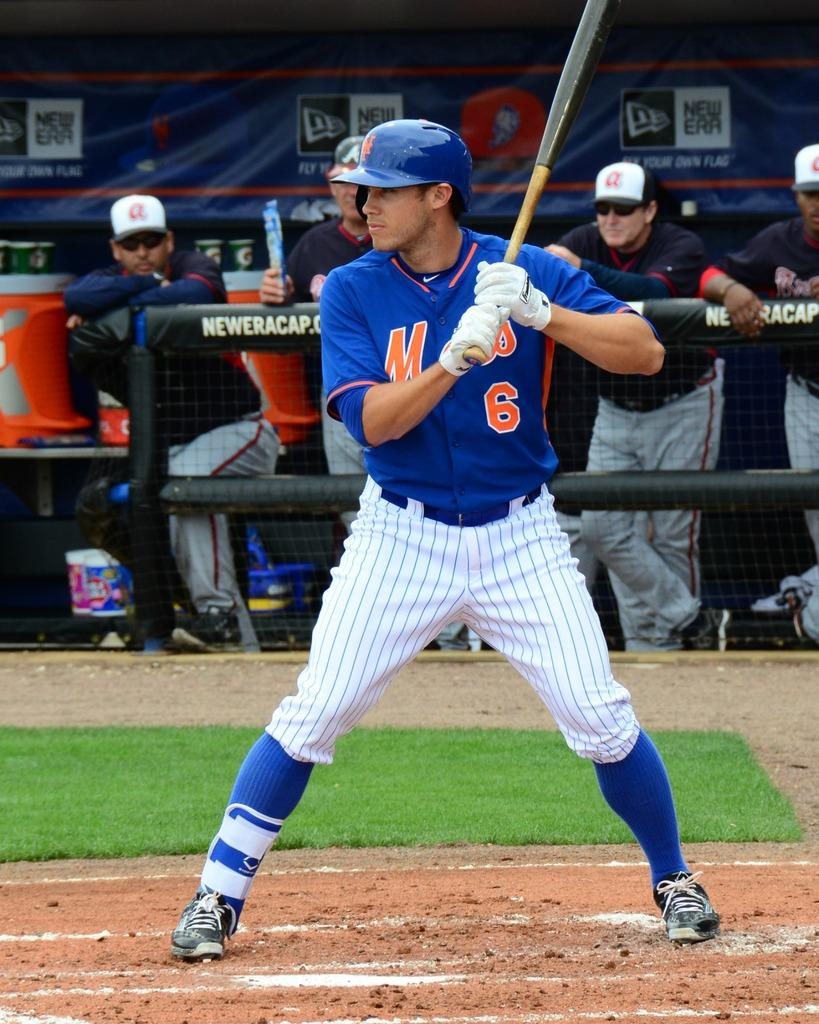<image>
Relay a brief, clear account of the picture shown. The batther is in a batting stance on the baseball field and is wearing a blue number uniform 